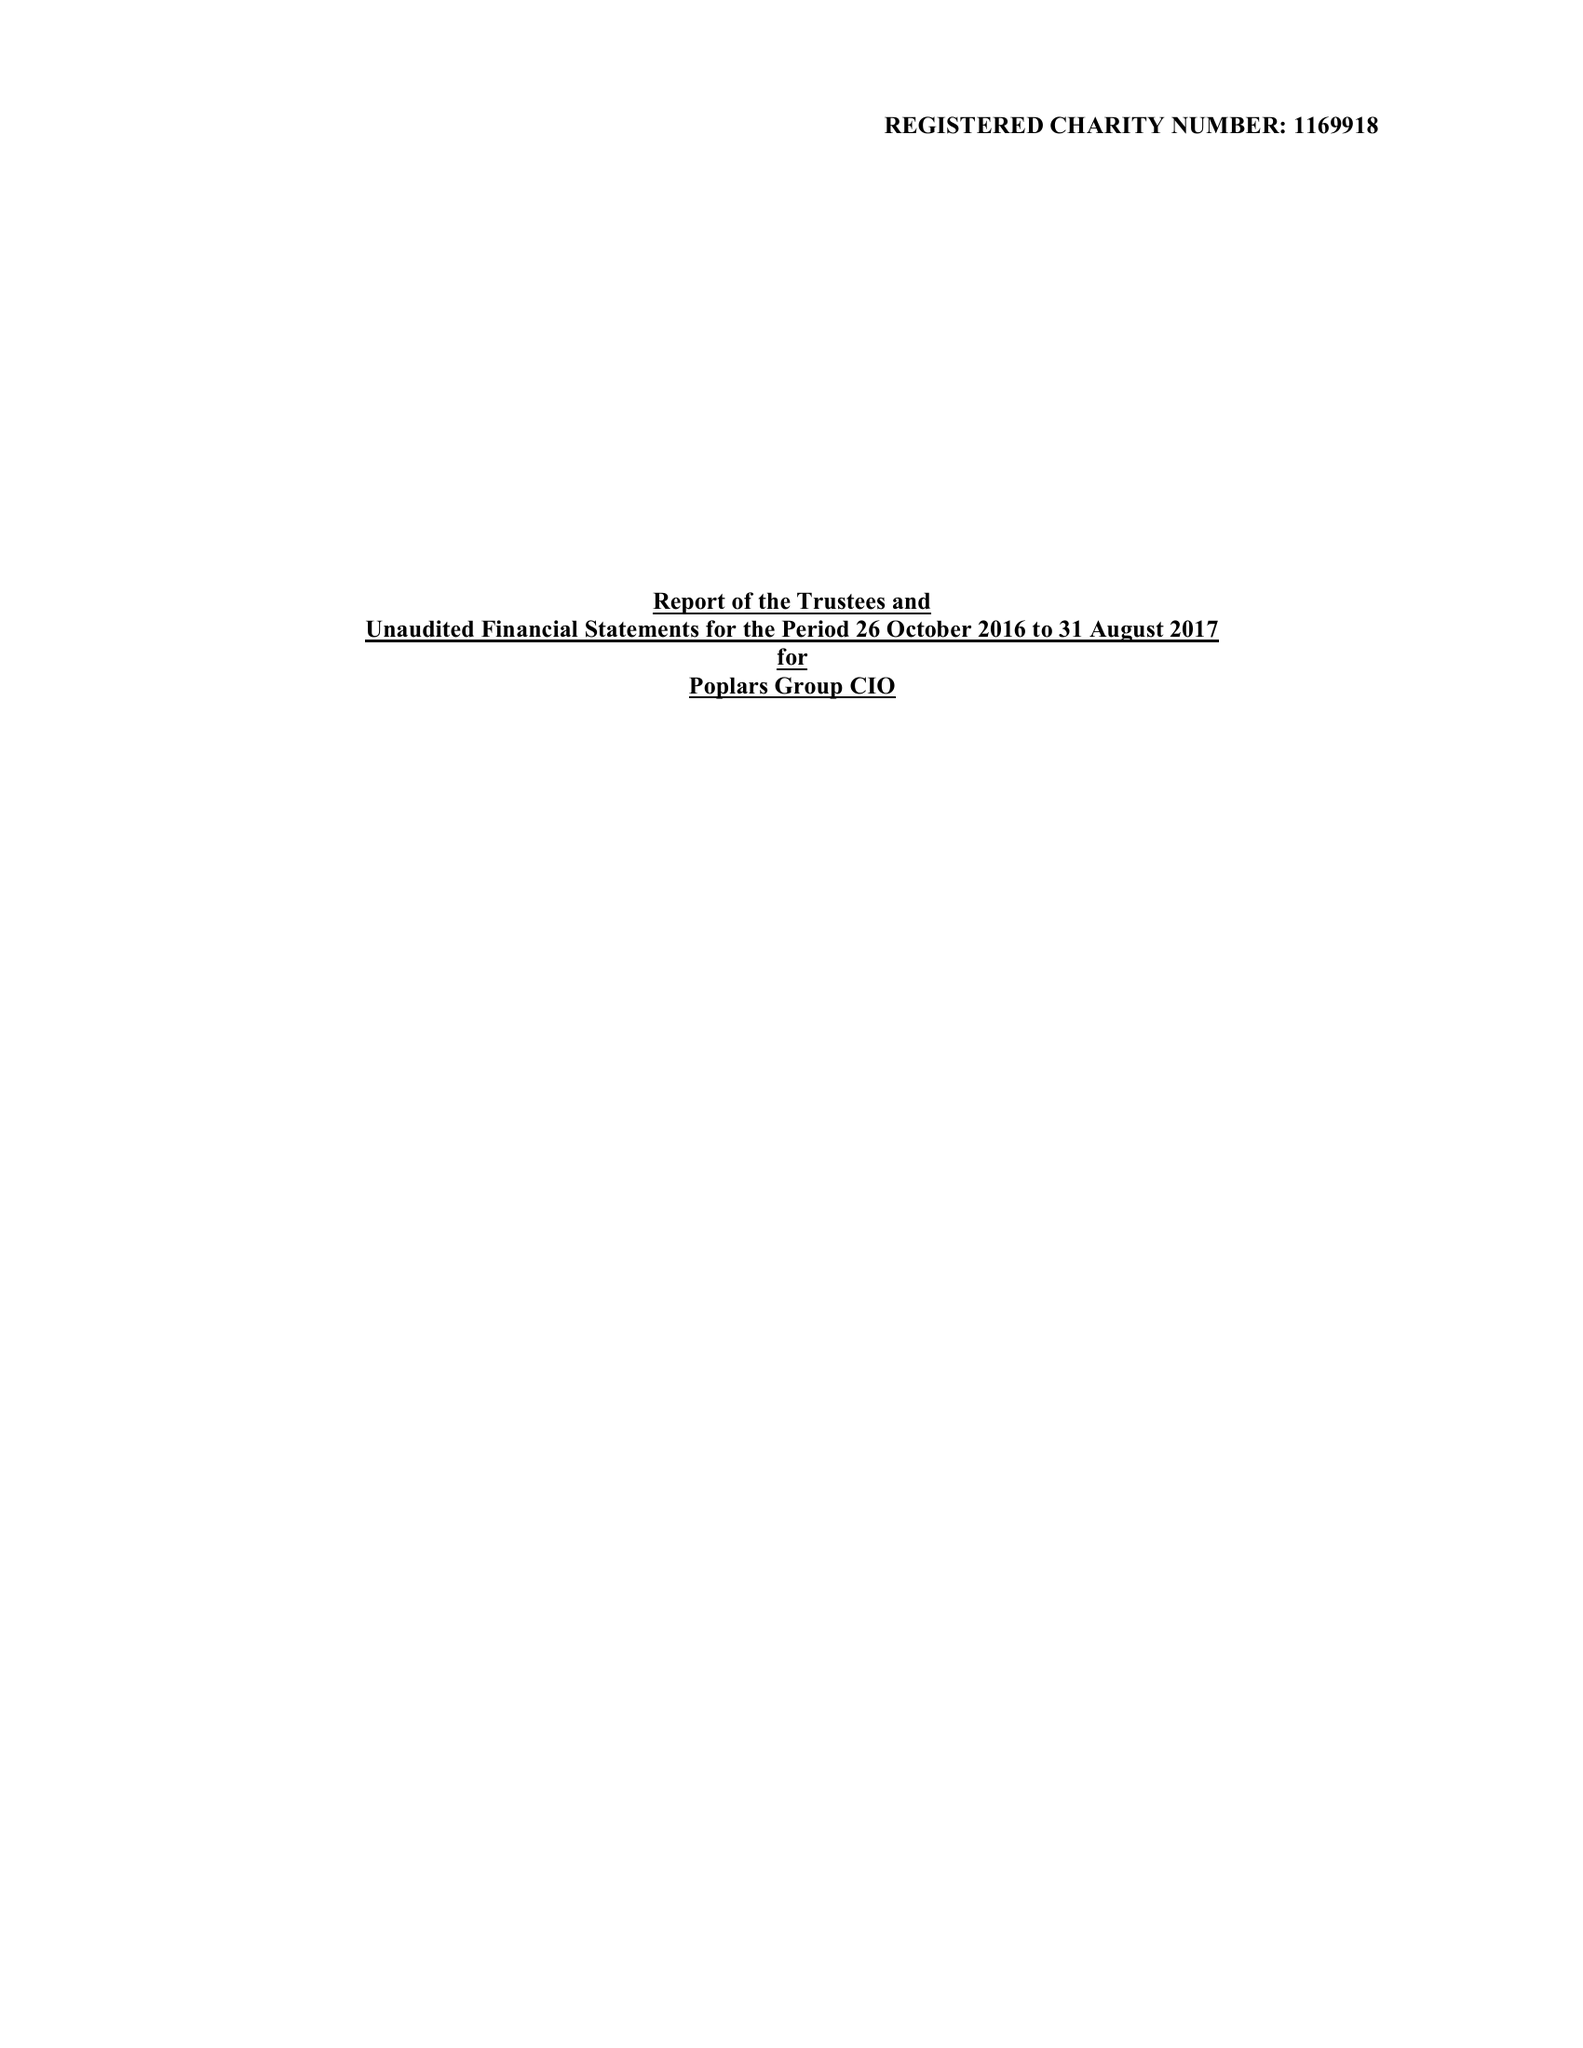What is the value for the spending_annually_in_british_pounds?
Answer the question using a single word or phrase. None 